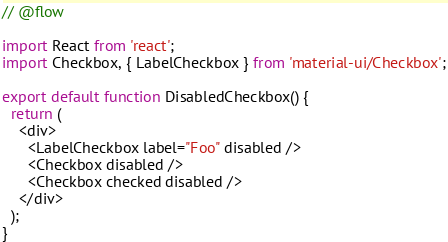<code> <loc_0><loc_0><loc_500><loc_500><_JavaScript_>// @flow

import React from 'react';
import Checkbox, { LabelCheckbox } from 'material-ui/Checkbox';

export default function DisabledCheckbox() {
  return (
    <div>
      <LabelCheckbox label="Foo" disabled />
      <Checkbox disabled />
      <Checkbox checked disabled />
    </div>
  );
}
</code> 